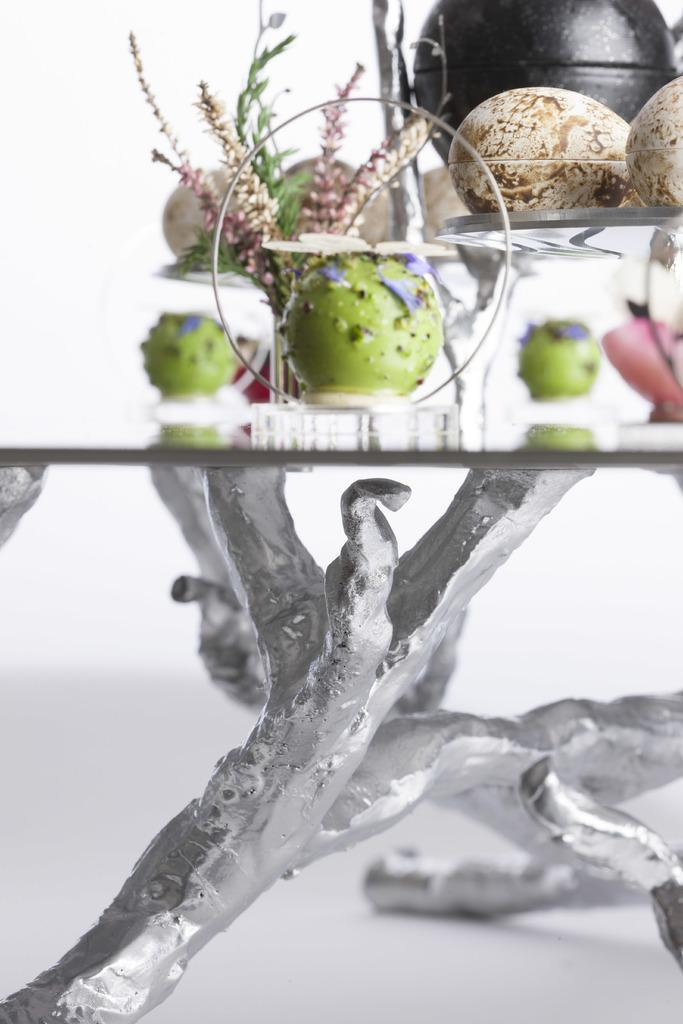What type of image is being described? The image is a collage. How is the collage divided? The bottom part of the image is black and white, while the top part is in color. What can be seen in the black and white section? There is a stand visible in the black and white section. What is present in the top part of the image? There is a plant and other objects in the top part of the image. How many cannons are present in the image? There are no cannons present in the image. What does the plant look like in the image? The provided facts do not describe the appearance of the plant, only its presence in the image. 